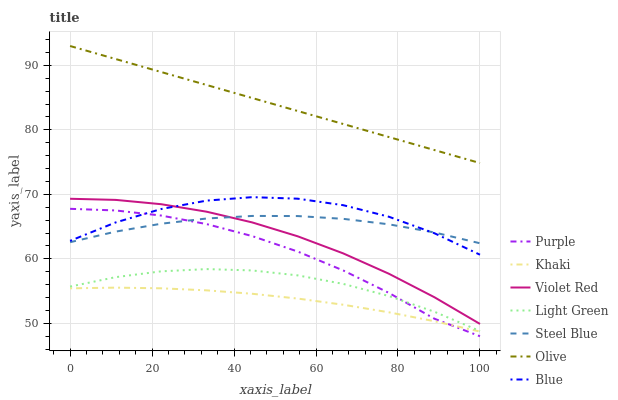Does Khaki have the minimum area under the curve?
Answer yes or no. Yes. Does Olive have the maximum area under the curve?
Answer yes or no. Yes. Does Violet Red have the minimum area under the curve?
Answer yes or no. No. Does Violet Red have the maximum area under the curve?
Answer yes or no. No. Is Olive the smoothest?
Answer yes or no. Yes. Is Blue the roughest?
Answer yes or no. Yes. Is Violet Red the smoothest?
Answer yes or no. No. Is Violet Red the roughest?
Answer yes or no. No. Does Purple have the lowest value?
Answer yes or no. Yes. Does Violet Red have the lowest value?
Answer yes or no. No. Does Olive have the highest value?
Answer yes or no. Yes. Does Violet Red have the highest value?
Answer yes or no. No. Is Light Green less than Blue?
Answer yes or no. Yes. Is Olive greater than Purple?
Answer yes or no. Yes. Does Blue intersect Steel Blue?
Answer yes or no. Yes. Is Blue less than Steel Blue?
Answer yes or no. No. Is Blue greater than Steel Blue?
Answer yes or no. No. Does Light Green intersect Blue?
Answer yes or no. No. 